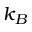<formula> <loc_0><loc_0><loc_500><loc_500>k _ { B }</formula> 